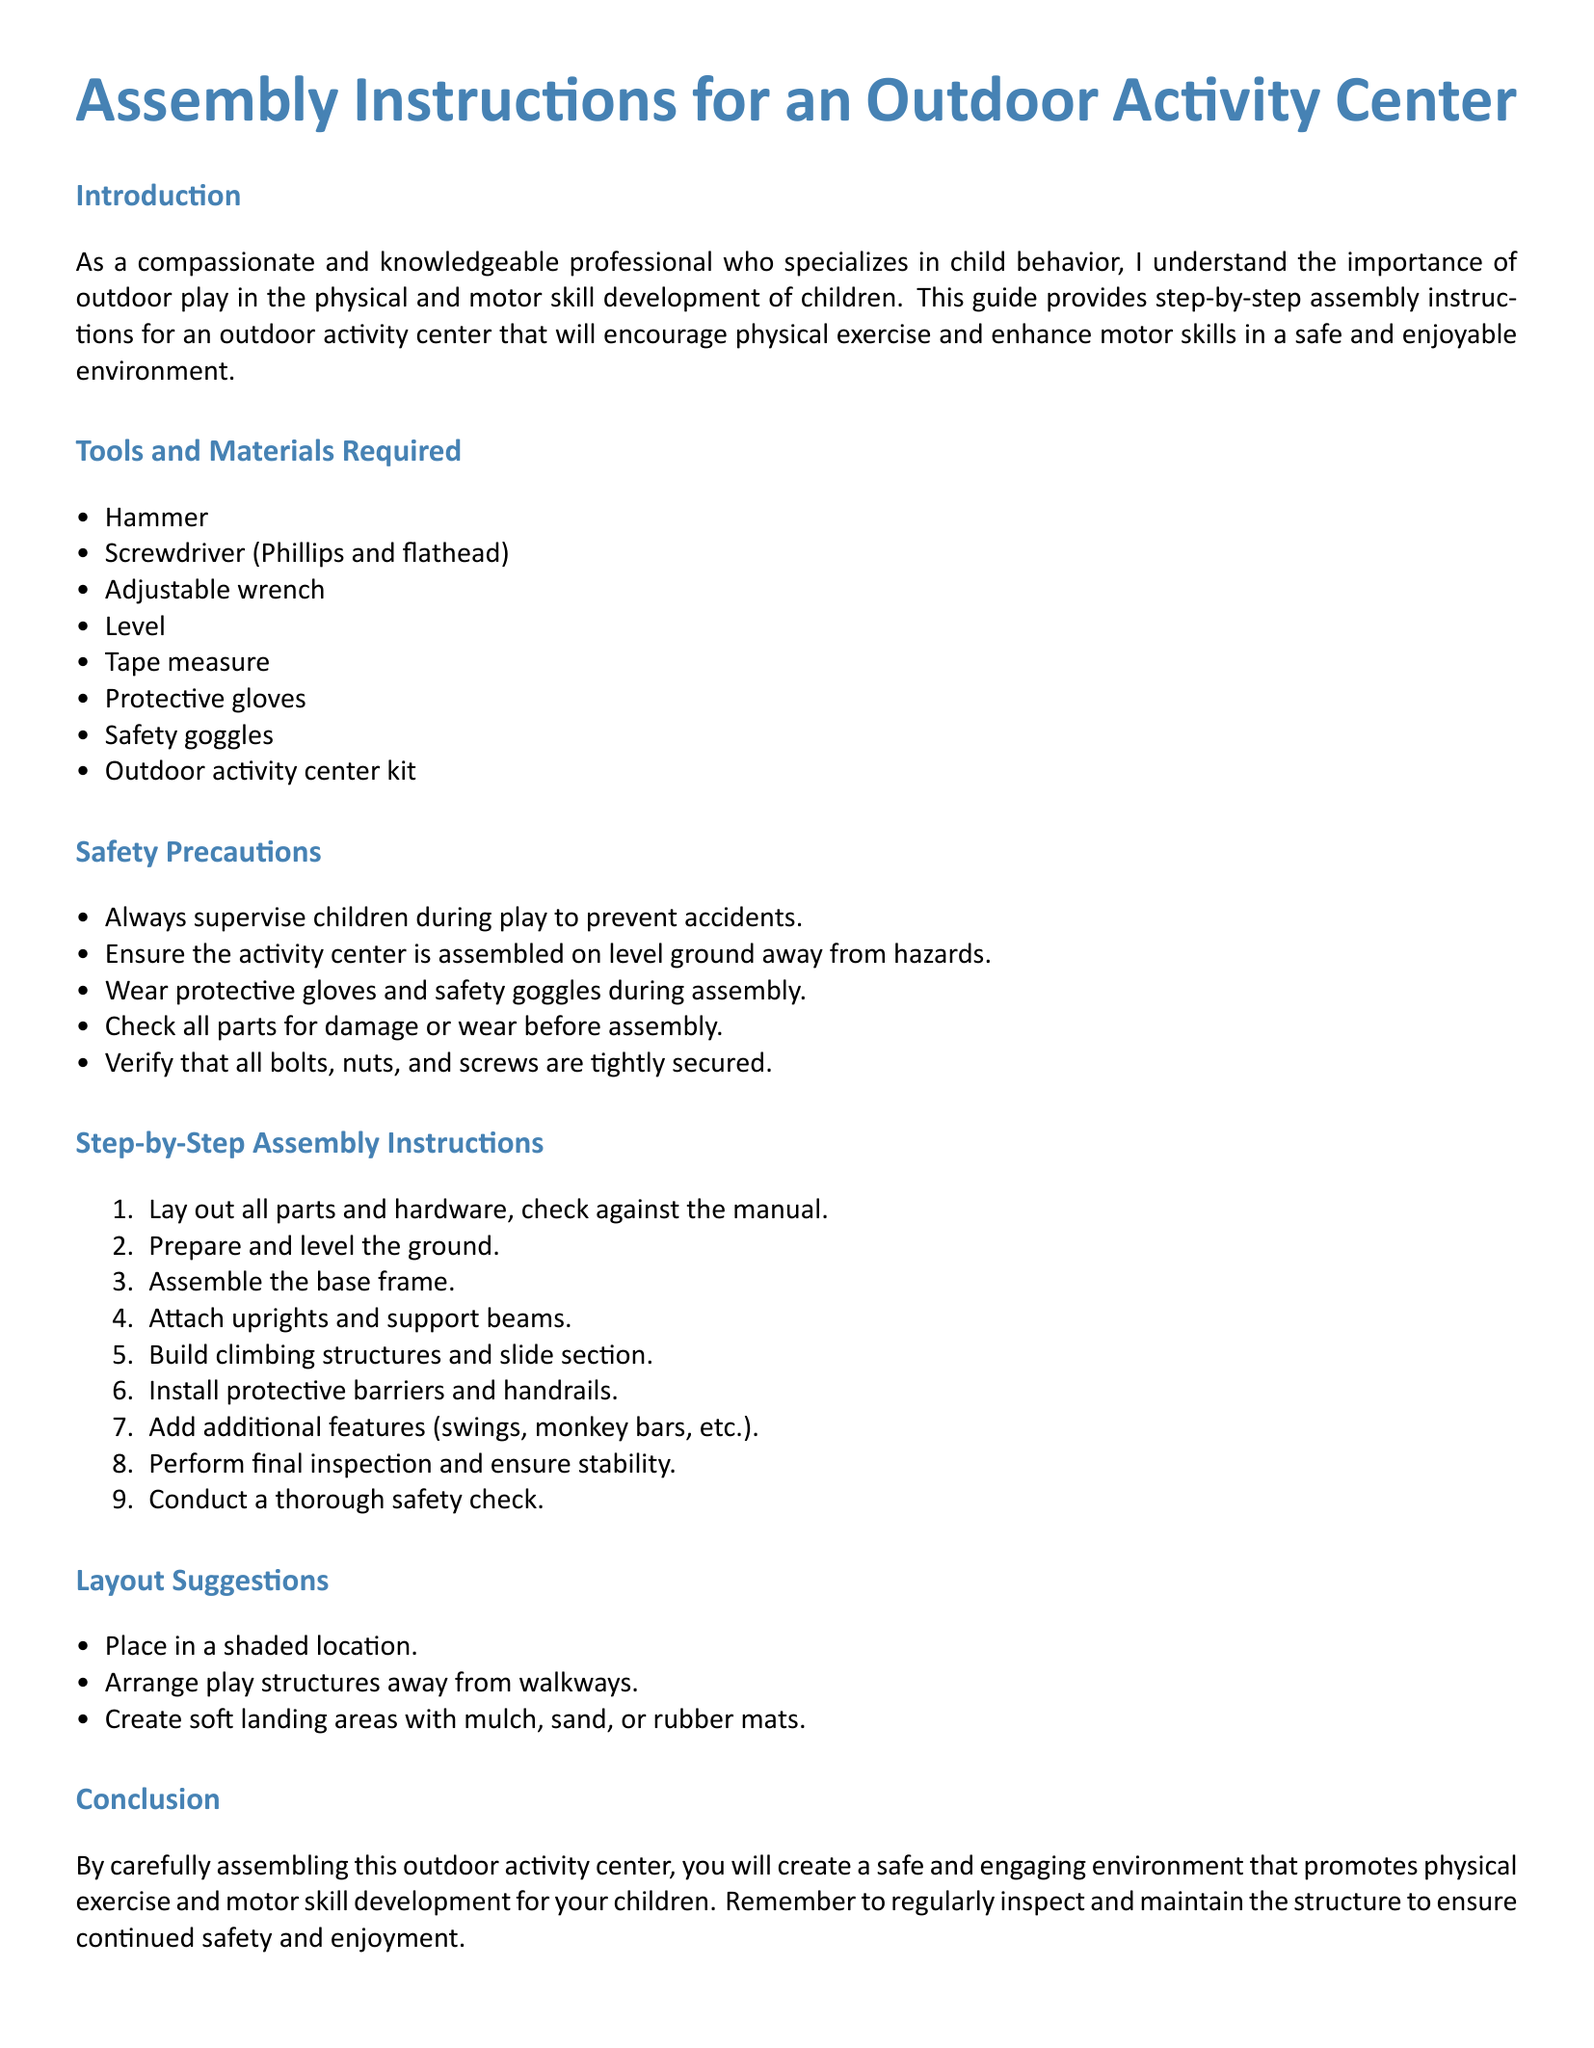What tools are required? The list of tools is provided in the "Tools and Materials Required" section, which includes a hammer, screwdriver, and more.
Answer: Hammer, Screwdriver, Adjustable wrench, Level, Tape measure, Protective gloves, Safety goggles How many assembly steps are there? The number of steps is indicated in the "Step-by-Step Assembly Instructions" section, where nine steps are listed.
Answer: Nine What should be checked before assembly? The safety precautions mention that all parts should be checked for damage or wear before assembly.
Answer: Damage or wear What is one of the safety precautions? The document lists safety precautions that are crucial for children's safety during play. One of them is supervising children.
Answer: Supervise children How should the ground be prepared? The assembly instructions specify that the ground should be prepared and leveled before starting the assembly.
Answer: Level What features can be added to the activity center? The "Step-by-Step Assembly Instructions" section mentions additional features like swings and monkey bars that can be included.
Answer: Swings, monkey bars Where should the activity center be placed? The layout suggestions include placing the activity center in a shaded location for optimal play conditions.
Answer: Shaded location What type of surface is suggested for landing areas? The layout suggestions state using mulch, sand, or rubber mats for creating soft landing areas.
Answer: Mulch, sand, rubber mats 